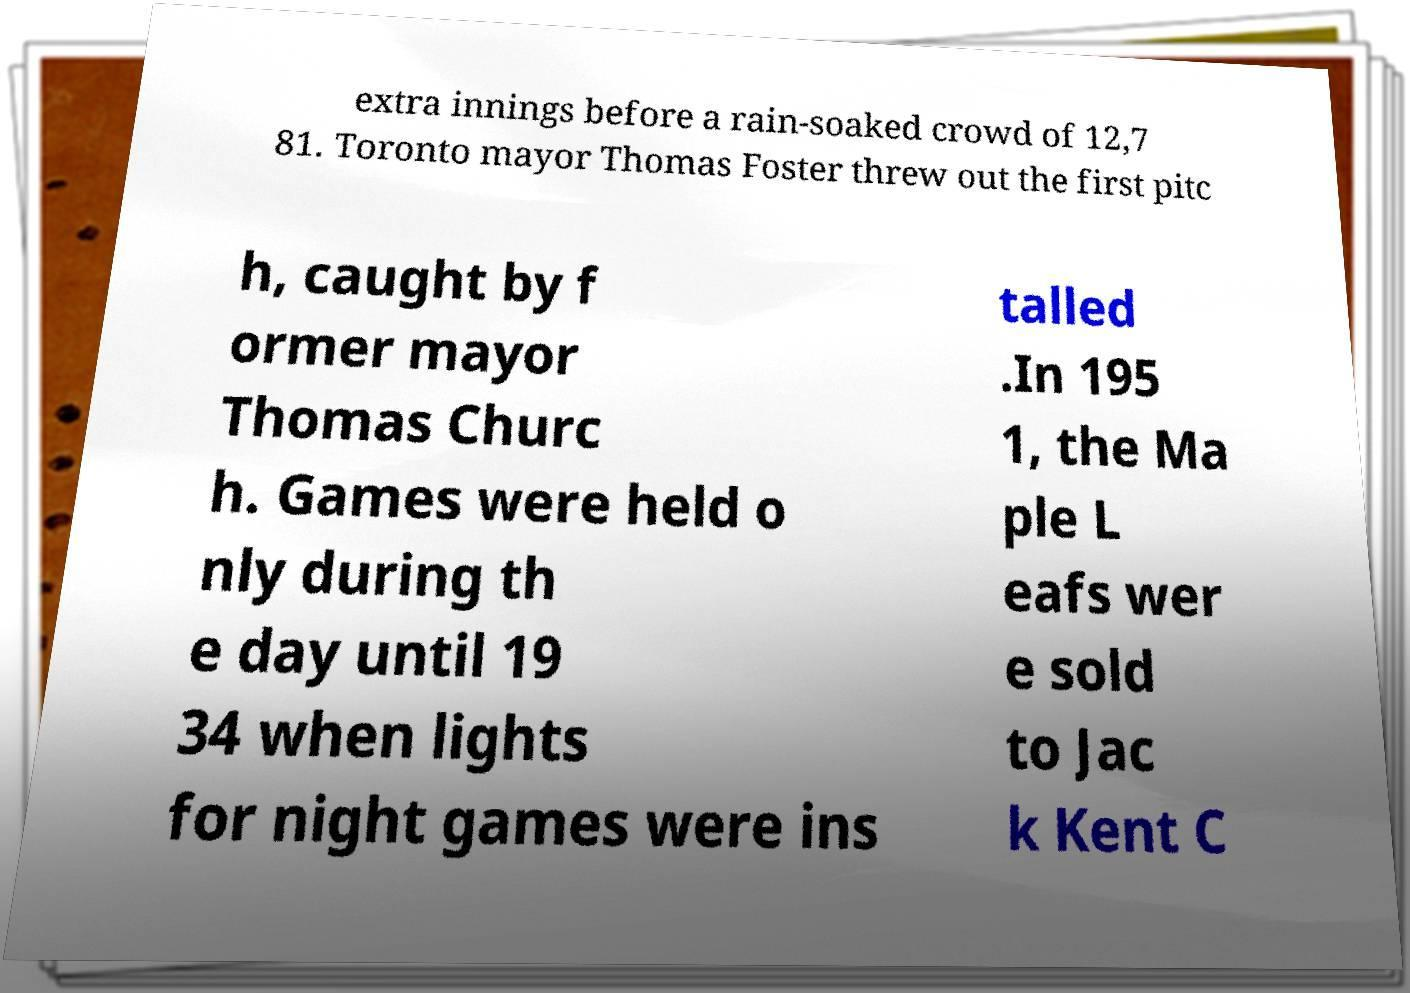Please read and relay the text visible in this image. What does it say? extra innings before a rain-soaked crowd of 12,7 81. Toronto mayor Thomas Foster threw out the first pitc h, caught by f ormer mayor Thomas Churc h. Games were held o nly during th e day until 19 34 when lights for night games were ins talled .In 195 1, the Ma ple L eafs wer e sold to Jac k Kent C 